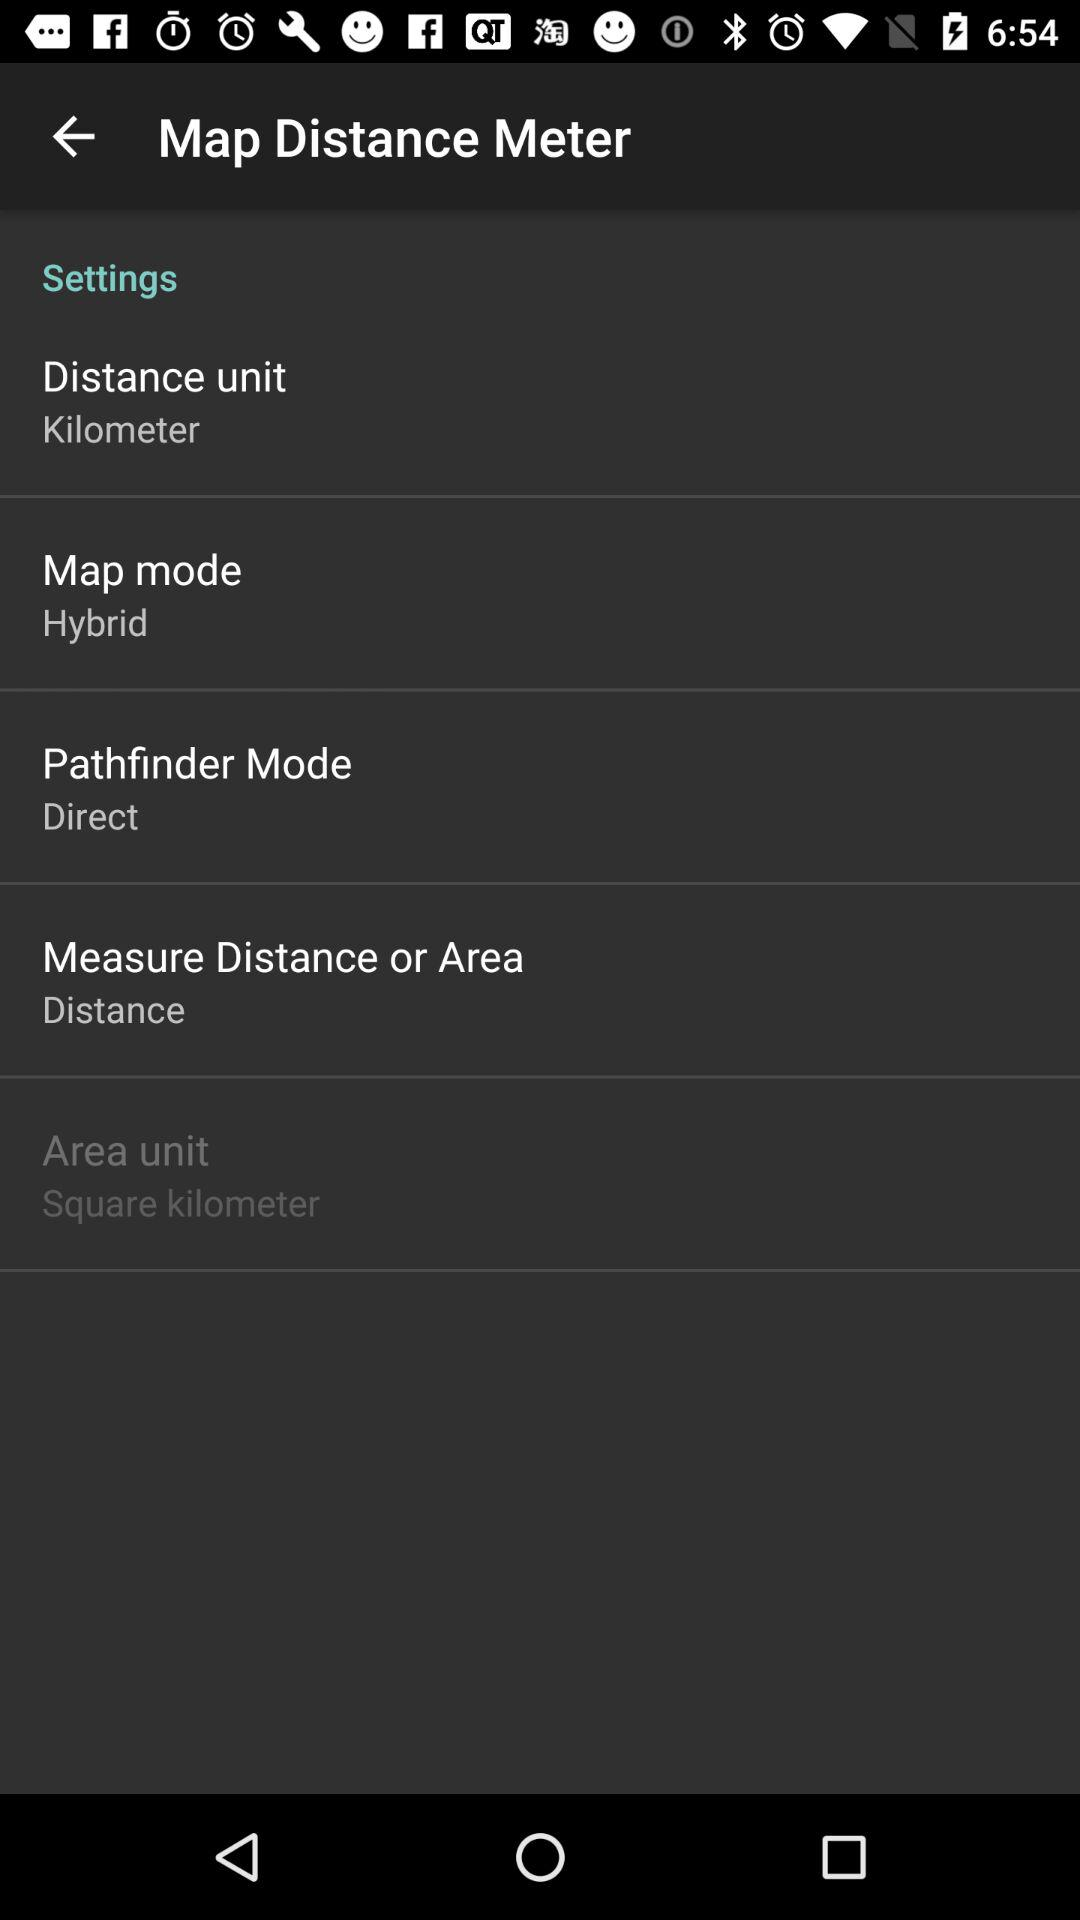How far is the map distance?
When the provided information is insufficient, respond with <no answer>. <no answer> 